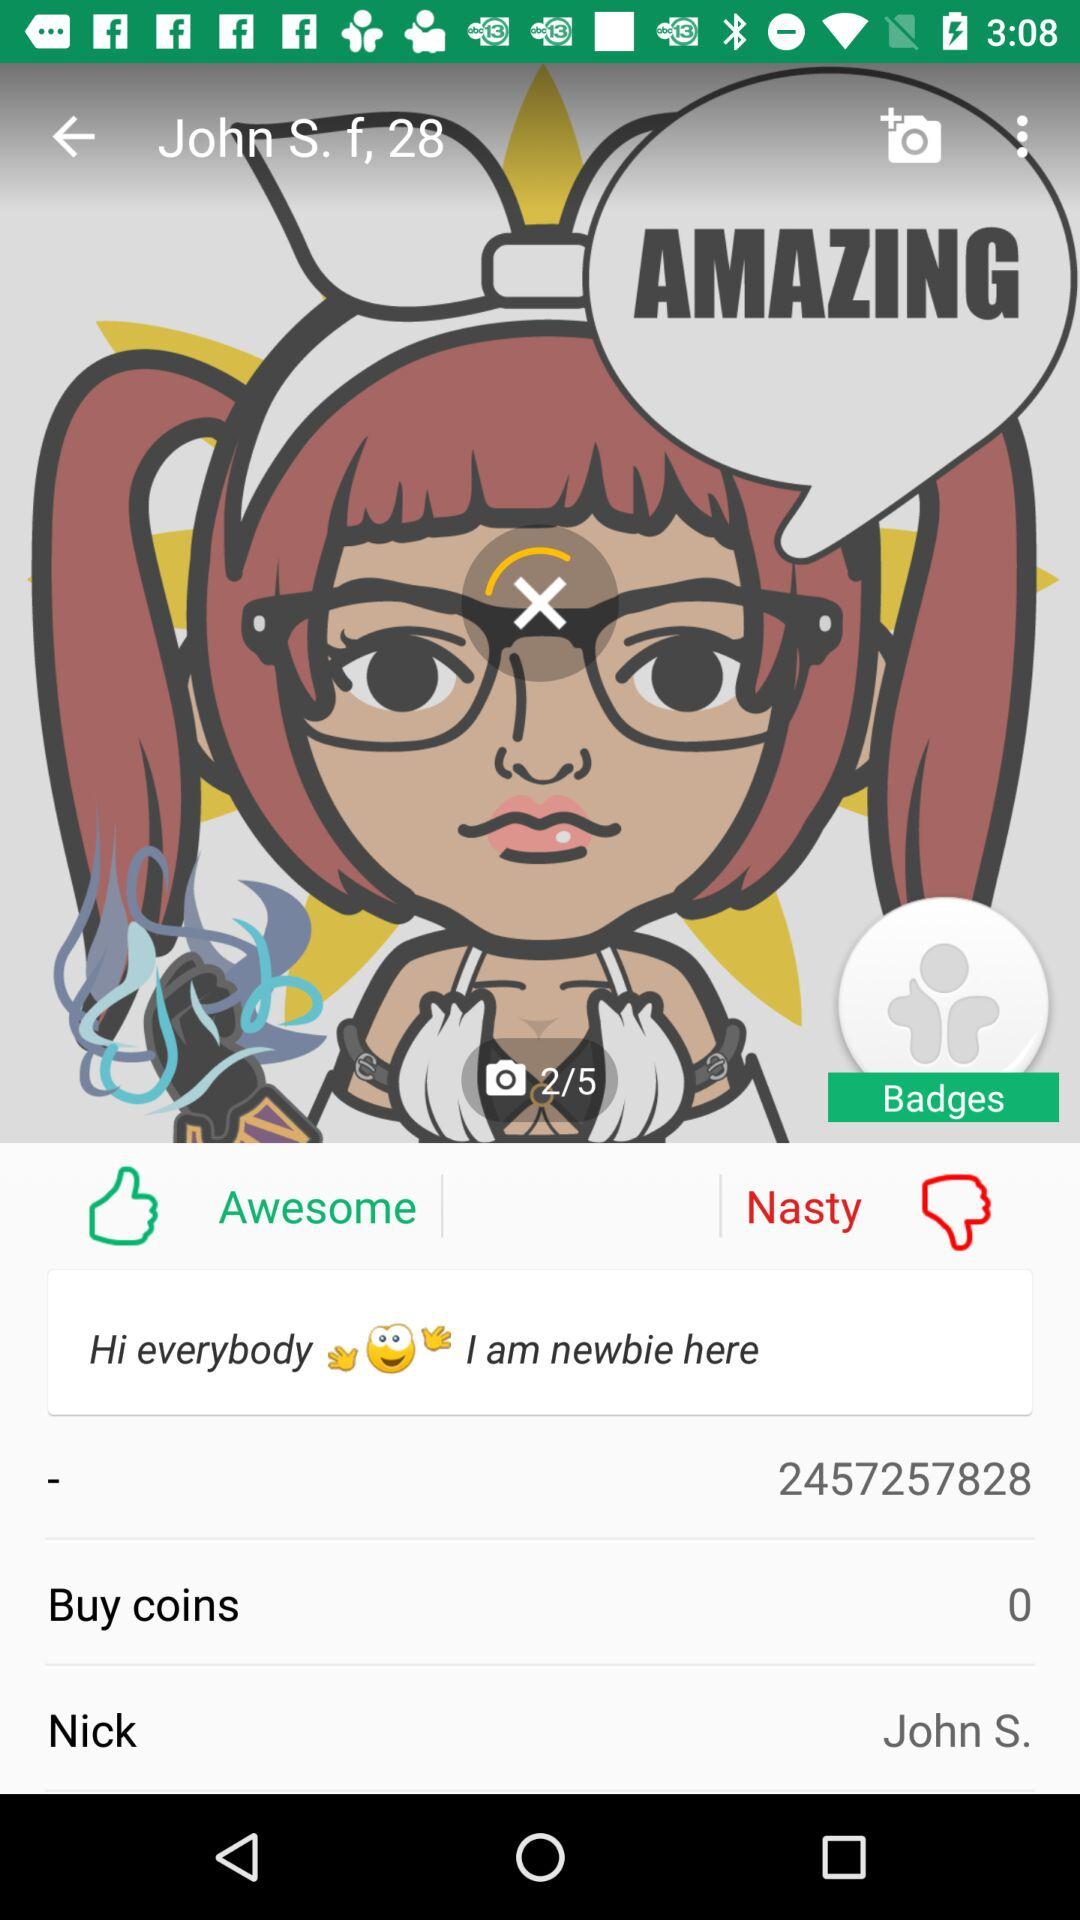What is the gender? The gender is female. 